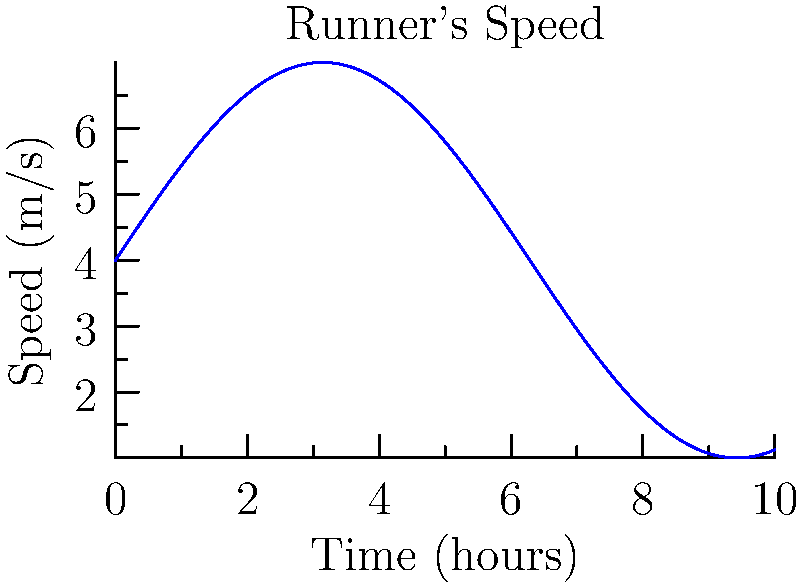As a graphics designer, you're creating a visual representation of a marathon runner's speed over time. The curve shown represents the runner's speed (in meters per second) as a function of time (in hours). If the marathon takes 5 hours to complete, what is the total distance covered by the runner in kilometers?

Assume the speed function is given by $s(t) = 3\sin(\frac{t}{2}) + 4$, where $t$ is time in hours and $s(t)$ is speed in meters per second. To solve this problem, we need to follow these steps:

1) The distance covered is the area under the speed-time curve. We can find this using integration.

2) The integral we need to calculate is:

   $$\text{Distance} = \int_0^5 s(t) dt = \int_0^5 (3\sin(\frac{t}{2}) + 4) dt$$

3) Let's integrate this function:
   
   $$\int_0^5 (3\sin(\frac{t}{2}) + 4) dt = [-6\cos(\frac{t}{2}) + 4t]_0^5$$

4) Evaluating the integral:
   
   $$= [-6\cos(\frac{5}{2}) + 4(5)] - [-6\cos(0) + 4(0)]$$
   $$= [-6\cos(\frac{5}{2}) + 20] - [-6 + 0]$$
   $$= -6\cos(\frac{5}{2}) + 26$$

5) Calculate this value:
   
   $$\approx -6(-0.8011) + 26 \approx 30.8066$$

6) This result is in meters per second * hours = meters

7) Convert to kilometers:
   
   $$30806.6 \text{ meters} = 30.8066 \text{ kilometers}$$
Answer: 30.81 km 